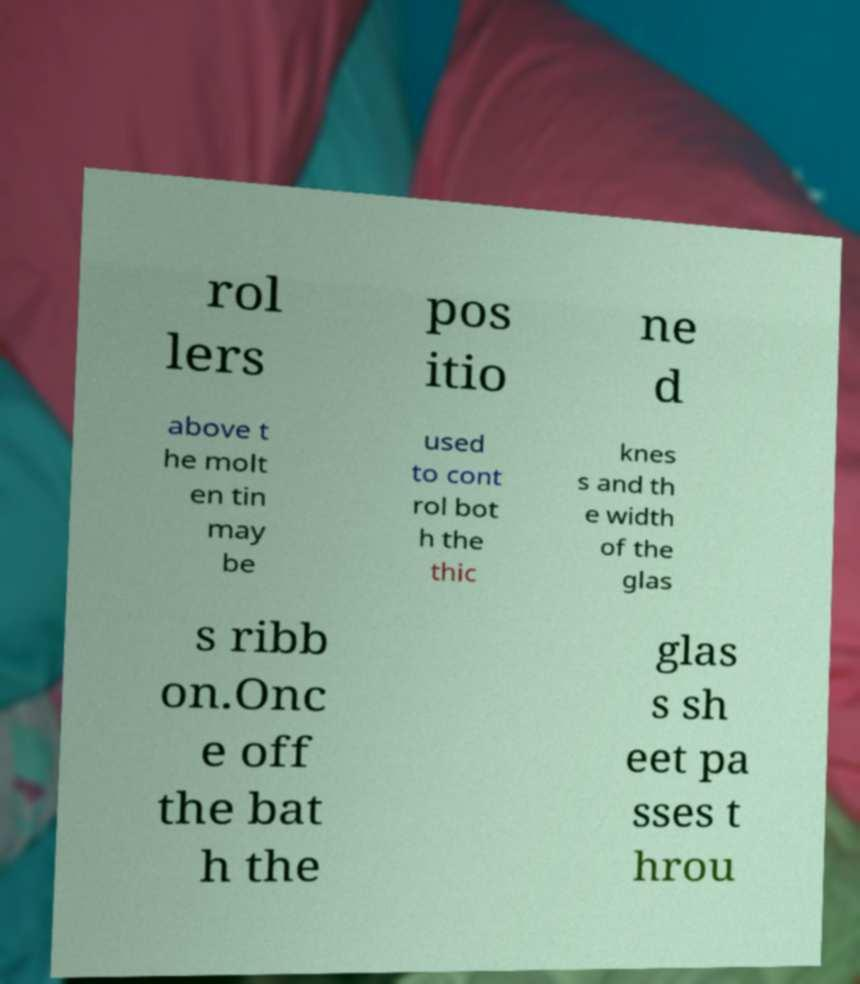For documentation purposes, I need the text within this image transcribed. Could you provide that? rol lers pos itio ne d above t he molt en tin may be used to cont rol bot h the thic knes s and th e width of the glas s ribb on.Onc e off the bat h the glas s sh eet pa sses t hrou 